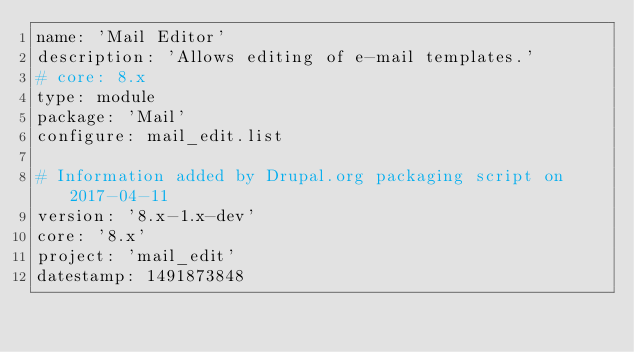<code> <loc_0><loc_0><loc_500><loc_500><_YAML_>name: 'Mail Editor'
description: 'Allows editing of e-mail templates.'
# core: 8.x
type: module
package: 'Mail'
configure: mail_edit.list

# Information added by Drupal.org packaging script on 2017-04-11
version: '8.x-1.x-dev'
core: '8.x'
project: 'mail_edit'
datestamp: 1491873848
</code> 